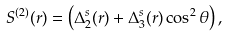Convert formula to latex. <formula><loc_0><loc_0><loc_500><loc_500>S ^ { ( 2 ) } ( { r } ) = \left ( \Delta _ { 2 } ^ { s } ( r ) + \Delta _ { 3 } ^ { s } ( r ) \cos ^ { 2 } \theta \right ) ,</formula> 